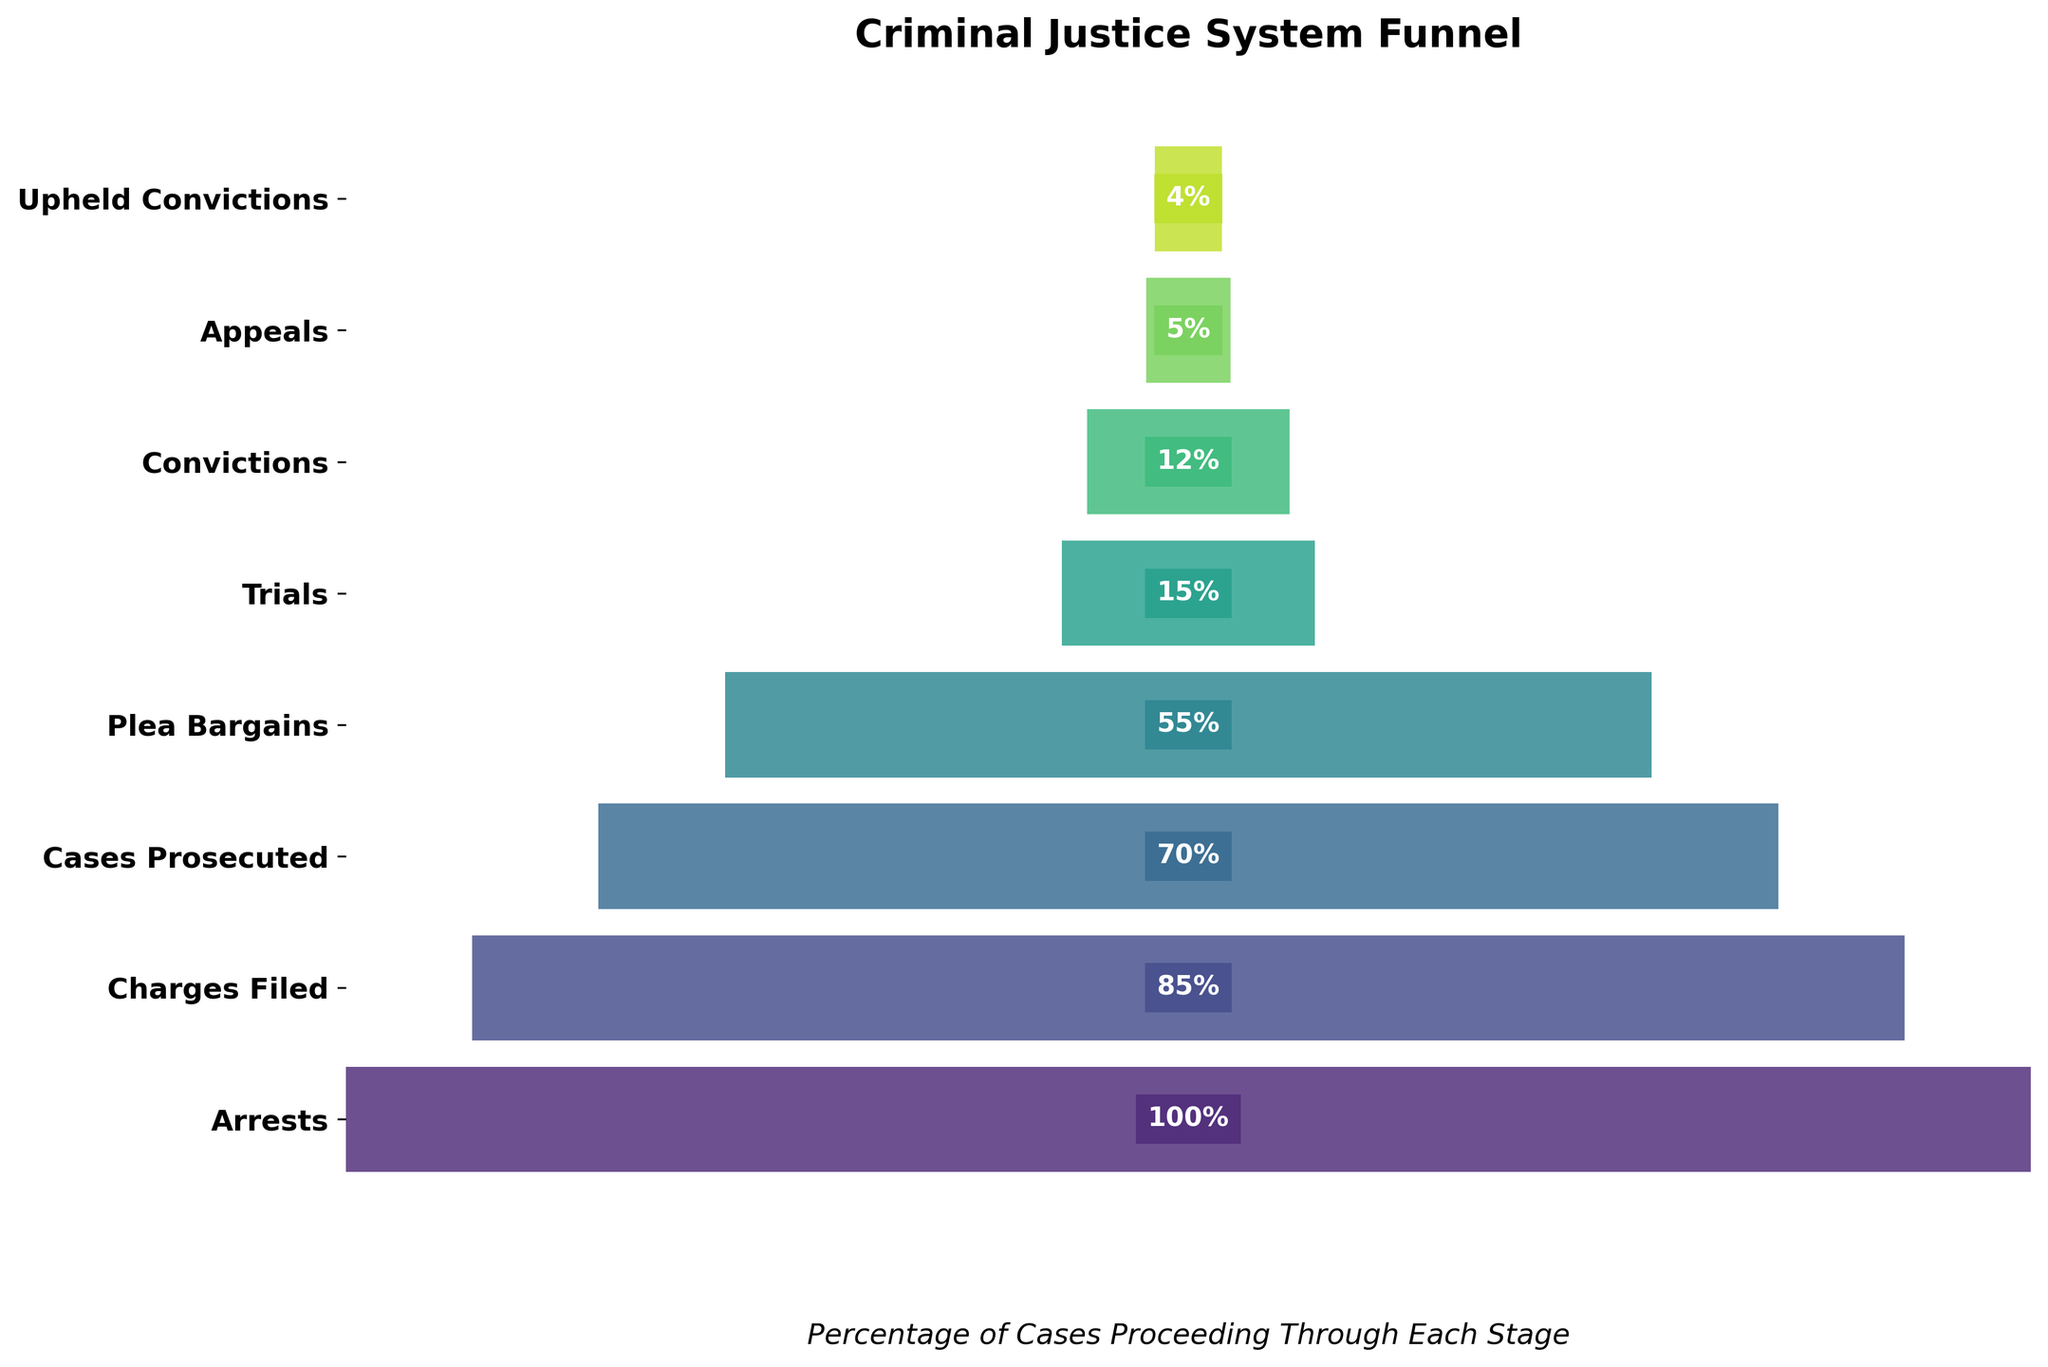What's the title of the funnel chart? The title of the chart is typically displayed at the top of the figure, which in this case is "Criminal Justice System Funnel".
Answer: Criminal Justice System Funnel What percentage of cases proceeds to plea bargains? To determine this, look at the stage labeled "Plea Bargains" and see the corresponding percentage value, which is 55%.
Answer: 55% How many stages are depicted in the funnel chart? Count the number of unique stages listed along the y-axis of the chart. The stages are: Arrests, Charges Filed, Cases Prosecuted, Plea Bargains, Trials, Convictions, Appeals, and Upheld Convictions, making a total of 8 stages.
Answer: 8 Which stage shows the greatest reduction in percentage compared to the previous stage? Compare the difference in percentages between consecutive stages: from Arrests (100%) to Charges Filed (85%) the reduction is 15%; from Charges Filed (85%) to Cases Prosecuted (70%) it is 15%; from Cases Prosecuted (70%) to Plea Bargains (55%) it is 15%; from Plea Bargains (55%) to Trials (15%) it is 40%; from Trials (15%) to Convictions (12%) it is 3%; from Convictions (12%) to Appeals (5%) it is 7%; from Appeals (5%) to Upheld Convictions (4%) it is 1%. The greatest reduction is 40%, which occurs between "Plea Bargains" and "Trials".
Answer: Plea Bargains to Trials How does the percentage of convictions compare to the percentage of cases prosecuted? To find this, locate the percentages for the "Convictions" and "Cases Prosecuted" stages. Convictions are at 12% and Cases Prosecuted are at 70%.
Answer: Convictions (12%) are lower than Cases Prosecuted (70%) What is the overall percentage drop from arrests to upheld convictions? The percentage drop is calculated by subtracting the final stage percentage (Upheld Convictions) from the initial stage percentage (Arrests). This is 100% - 4% = 96%.
Answer: 96% Calculate the average percentage of the stages starting from charges filed to upheld convictions. Sum the percentages from "Charges Filed" (85%), "Cases Prosecuted" (70%), "Plea Bargains" (55%), "Trials" (15%), "Convictions" (12%), "Appeals" (5%), and "Upheld Convictions" (4%), then divide by the number of stages (7): (85 + 70 + 55 + 15 + 12 + 5 + 4) / 7 ≈ 35.14%.
Answer: Approximately 35.14% What is the color scheme used in the funnel chart? The colors in the funnel chart are gradient shades of a single color scheme, specifically from lighter to darker shades, indicating a continuous color scale, likely from green or blue (commonly used as these provide good contrast).
Answer: Gradient shades (e.g., green or blue) How do the percentages of trials and convictions compare? Look at the percentages for "Trials" and "Convictions". Trials are at 15%, while Convictions are at 12%.
Answer: Trials (15%) are greater than Convictions (12%) What insight can be drawn from the funnel chart about the criminal justice process's efficiency in maintaining convictions throughout the appeal process? The insight can be drawn by observing the percentage drop from "Convictions" (12%) to "Upheld Convictions" (4%), indicating a significant reduction through the appeals process. This shows that a notable portion of convictions are overturned, pointing to potential inefficiencies.
Answer: Significant reduction through appeals process 